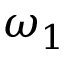<formula> <loc_0><loc_0><loc_500><loc_500>\omega _ { 1 }</formula> 